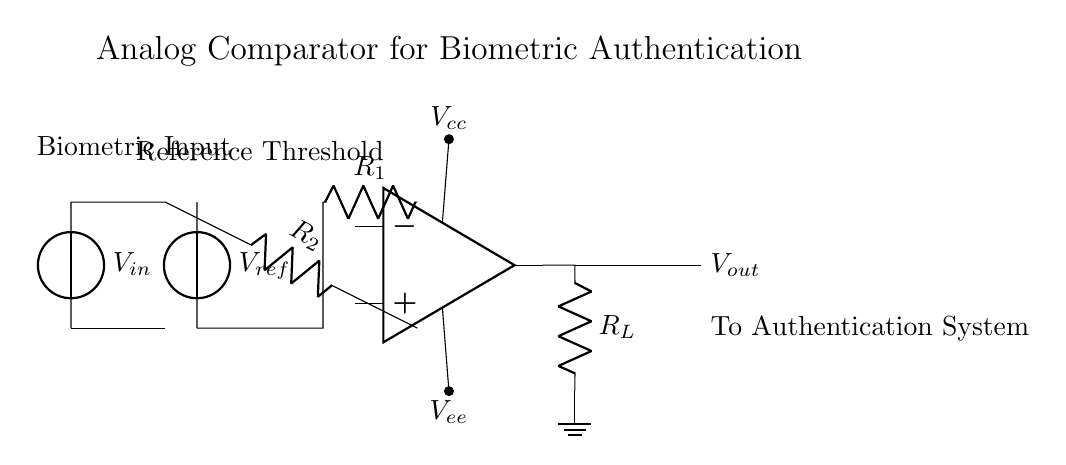What is the reference voltage in this circuit? The reference voltage, indicated by the voltage source labeled V_ref, is used to compare against the input voltage. The specific value is typically determined by the design but is not given in the diagram itself.
Answer: V_ref What component functions as an operational amplifier? The symbol representing the operational amplifier in the diagram is shown very clearly. It typically has three terminals for inverting, non-inverting inputs, and an output, which is distinctly represented.
Answer: Operational amplifier What are the resistor values in this circuit? The resistors are labeled as R1 and R2. However, the specific resistance values are not shown in the circuit diagram. These resistors are part of the voltage divider and affect the comparator operation.
Answer: R1, R2 How does the circuit determine if the biometric input is valid? The circuit compares the biometric input voltage with the reference voltage. If the input voltage exceeds the reference voltage, the output changes state, indicating a valid authentication; otherwise, it remains low.
Answer: By comparison with V_ref What does V_out represent in the context of this circuit? The output voltage (V_out) reflects the result of the comparison between the input voltage and reference voltage. Depending on the comparison outcome, V_out will either drive high or low.
Answer: Outcome of the comparison Which component might limit the output current? The load resistor labeled R_L is connected to the output terminal, which likely limits the current flowing to the subsequent circuit.
Answer: R_L What role does the power supply play in this circuit? The voltage sources labeled V_cc and V_ee provide the necessary power for the operational amplifier to function properly, allowing it to amplify the difference between the input voltages.
Answer: Power for the op-amp 